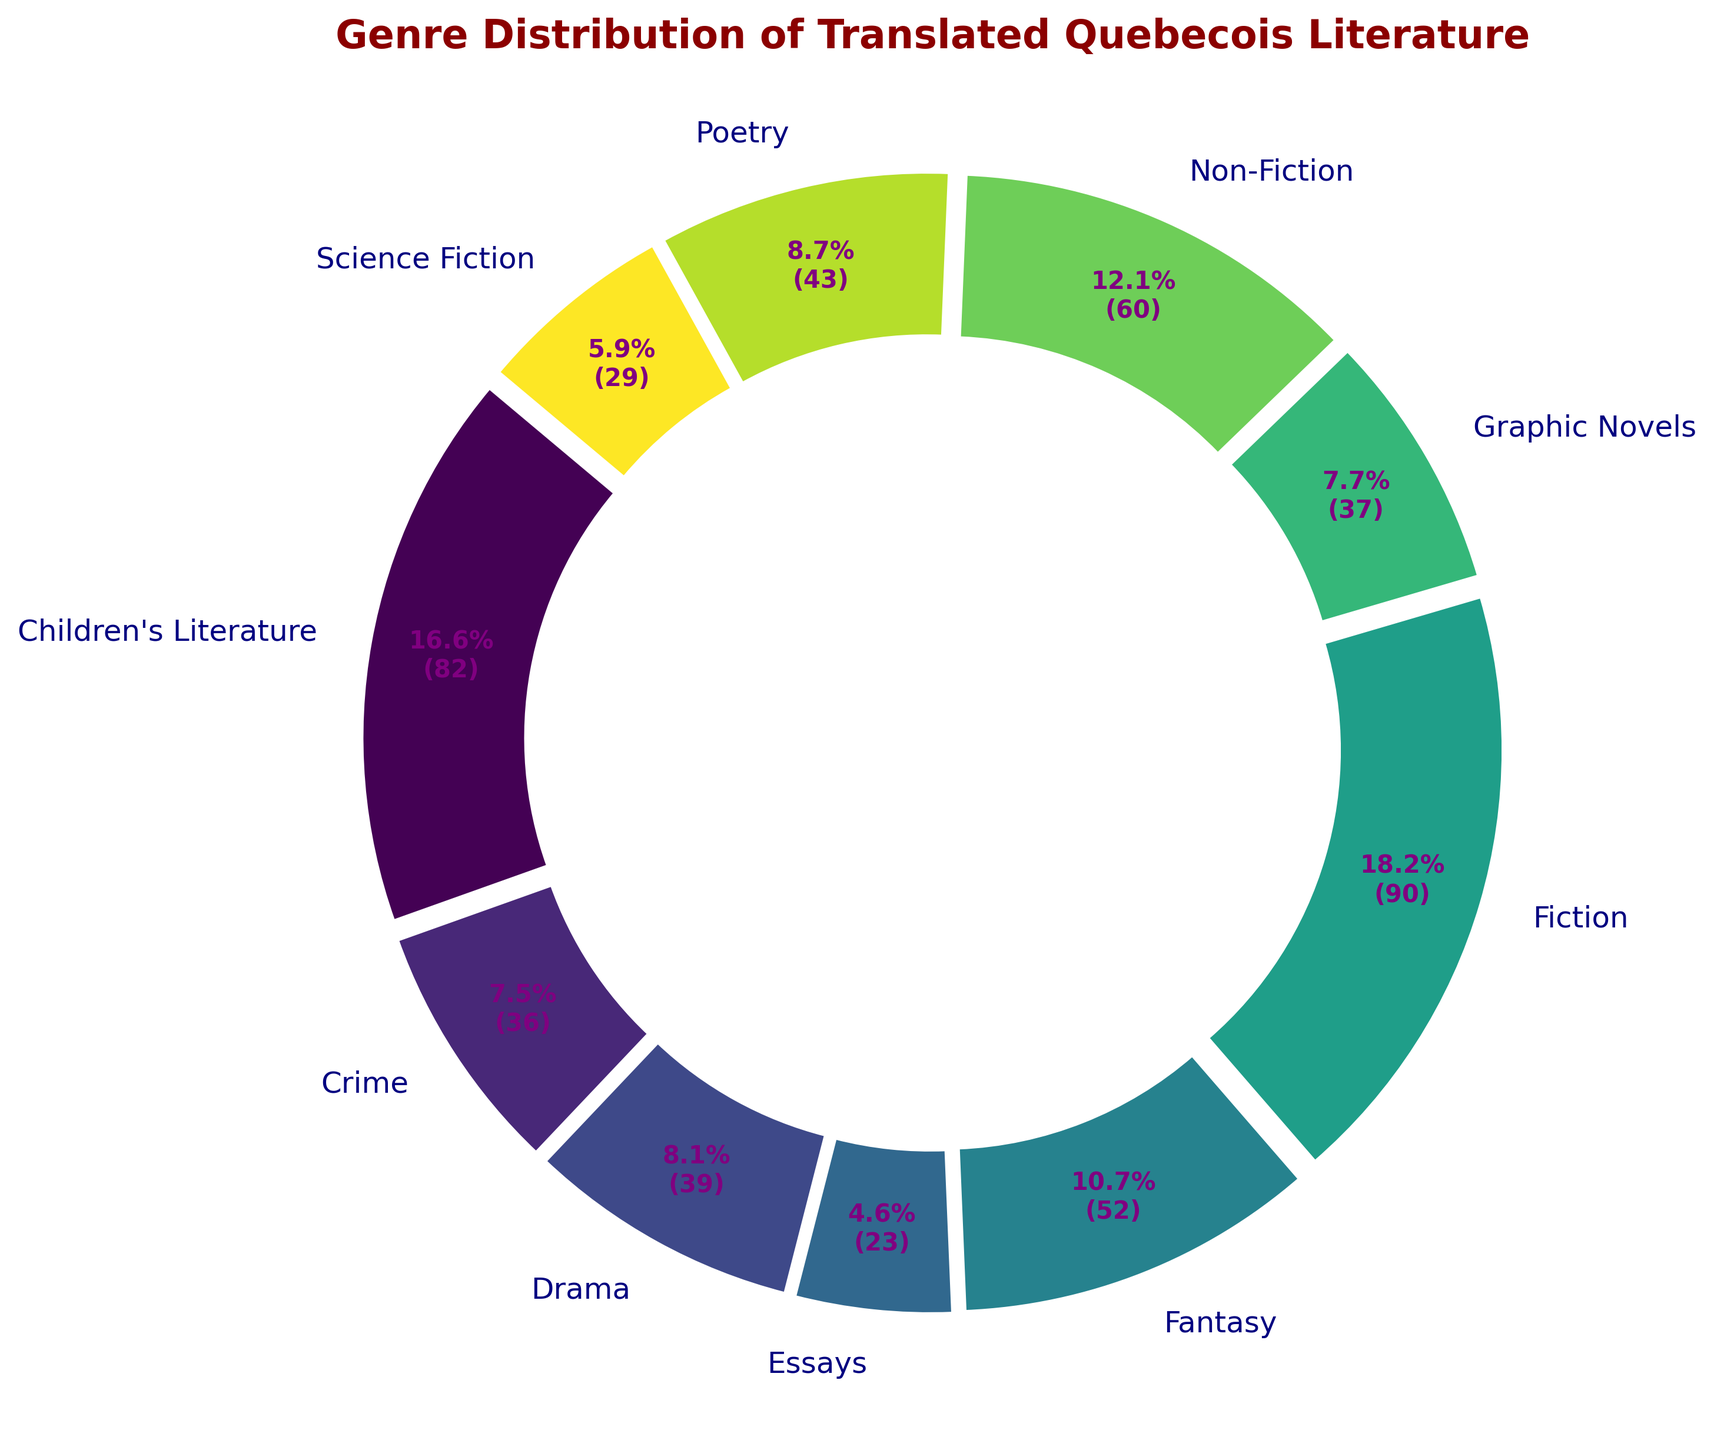What's the most common genre of Quebecois literature translated into various languages? The "Fiction" genre slice is the largest and visually the thickest in the ring, indicating it has the highest count.
Answer: Fiction Which genre has the smallest share in the translated Quebecois literature? By looking at the visual thickness of the slices, "Drama" and "Essays" appear among the smallest in the ring chart, but "Drama" is slightly bigger than "Essays". "Essays" has the smallest share.
Answer: Essays What is the combined percentage of Fiction and Non-Fiction in translated Quebecois literature? Fiction and Non-Fiction are the two largest slices in the chart. Noting their overall contribution, a simple sum of the percentages (57.5% from Fiction and 27.5% from Non-Fiction) provides the combined percentage.
Answer: 85% Which genre has a percentage closest to 10%? In the ring chart, the slice for "Children's Literature" looks closest to 10%, as calculated via relative visual segment sizes among the other genres.
Answer: Children's Literature How many more translated works are there in the Fiction genre compared to the Science Fiction genre? The chart shows Fiction with the highest count at 90, while Science Fiction has notably smaller width at 29. The difference is found by subtraction: 90 - 29.
Answer: 61 Compare the percentage of Children's Literature with Fantasy. Which one is higher? By examining the size of the slices, "Children’s Literature" and "Fantasy" have similar sized slices but "Children's Literature" has a larger portion of the ring chart.
Answer: Children's Literature If you add up the number of translated works in Poetry and Drama, what percentage of the total does it represent? Combine the counts for Poetry (43) and Drama (40). The total is 83. Dividing 83 by the overall count of translated Quebecois literature (329) and multiplying by 100 gives approx. 25.2%.
Answer: ~25.2% What genre has more translated works: Crime or Graphic Novels? The ring chart shows the slices for Crime and Graphic Novels. The slice for Crime appears larger, indicating more translated works.
Answer: Crime How much larger is the Fiction section compared to the Non-Fiction section by percentage points? Fiction stands at 57.5% and Non-Fiction at 27.5% as per the chart. Subtracting the two provides the difference: 57.5% - 27.5%.
Answer: 30% Which slice is visually represented in light green color? The genre that is colored light green in the ring chart is "Graphic Novels", as the color gradient progresses from dark to lighter hues.
Answer: Graphic Novels 